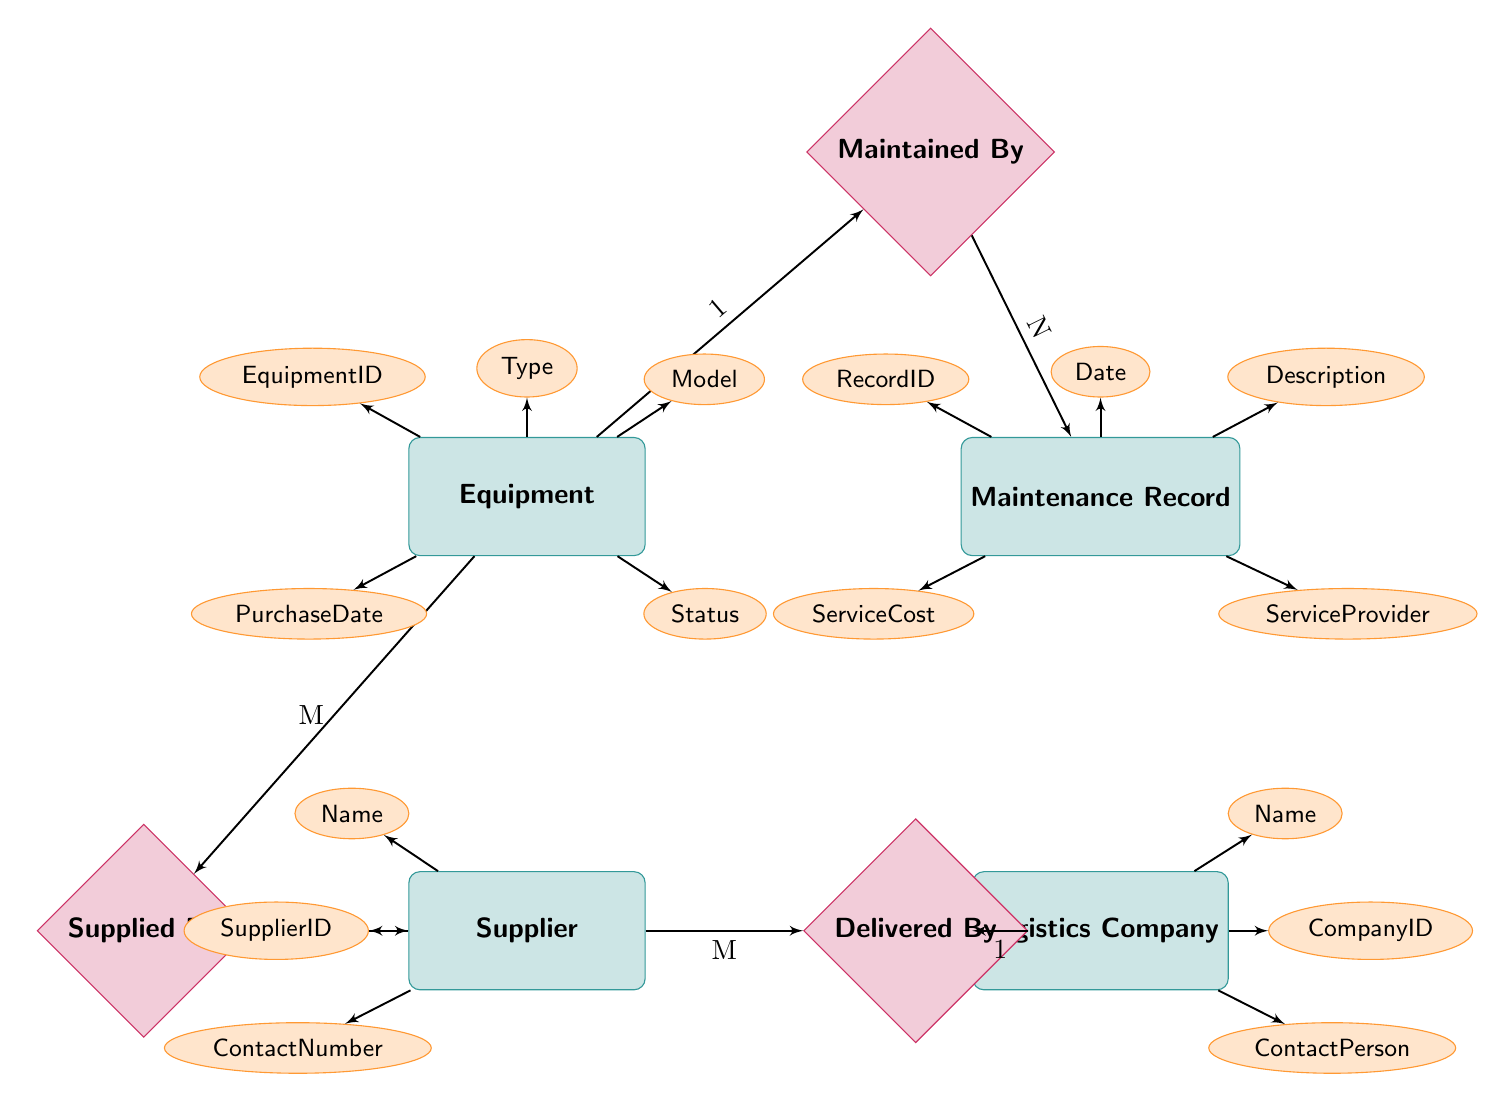What is the primary key of the Equipment entity? The primary key of the Equipment entity is EquipmentID, which uniquely identifies each piece of equipment in the diagram.
Answer: EquipmentID What is the relationship between Equipment and Maintenance Record? The relationship between Equipment and Maintenance Record is labeled as "Maintained By", indicating that one piece of equipment can have multiple maintenance records associated with it.
Answer: Maintained By How many relationships does the Supplier entity have? The Supplier entity has two relationships: "Supplied By" with Equipment and "Delivered By" with Logistics Company, indicating it serves as a midpoint in both flows.
Answer: 2 What is the cardinality of the relationship between Equipment and Supplier? The cardinality of the relationship between Equipment and Supplier is M:1, which means many pieces of equipment can be supplied by one supplier.
Answer: M:1 Which entity is connected to Logistics Company through the Delivered By relationship? The entity connected to Logistics Company through the Delivered By relationship is Supplier, indicating that the supplier relies on the logistics company for delivering equipment.
Answer: Supplier How many attributes does the Maintenance Record entity have? The Maintenance Record entity has five attributes: RecordID, Date, Description, ServiceCost, and ServiceProvider, detailing the specifics of each maintenance entry.
Answer: 5 What type of diagram is represented in this illustration? This illustration represents an Entity Relationship Diagram, which shows entities, their attributes, and how they are related to one another within a system, particularly for equipment maintenance and service records.
Answer: Entity Relationship Diagram Which attribute of Supplier is related to contact information? The contact information attribute related to Supplier is ContactNumber which provides the phone number for communication.
Answer: ContactNumber Who maintains the Equipment records? The Equipment records are maintained through the relationship labeled "Maintained By" with the Maintenance Record, indicating a direct link between equipment details and their records of maintenance.
Answer: Maintenance Record 